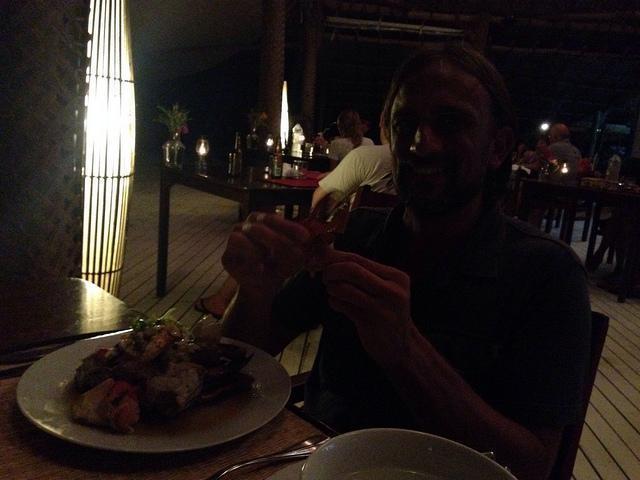What kind of food is the man consuming?
Pick the correct solution from the four options below to address the question.
Options: Steak, seafood, pork, lamb. Seafood. 